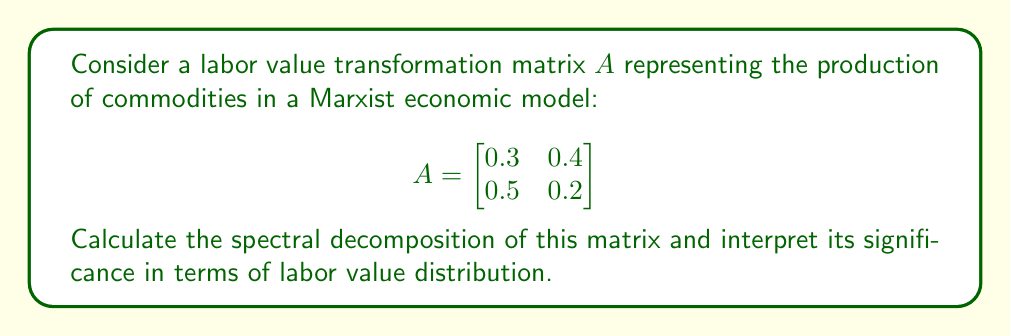Teach me how to tackle this problem. To calculate the spectral decomposition of matrix $A$, we follow these steps:

1) Find the eigenvalues of $A$:
   Characteristic equation: $det(A - \lambda I) = 0$
   $$ \begin{vmatrix}
   0.3 - \lambda & 0.4 \\
   0.5 & 0.2 - \lambda
   \end{vmatrix} = 0 $$
   $(0.3 - \lambda)(0.2 - \lambda) - 0.2 = 0$
   $\lambda^2 - 0.5\lambda - 0.14 = 0$
   Solving this quadratic equation, we get:
   $\lambda_1 \approx 0.7236$ and $\lambda_2 \approx -0.2236$

2) Find the eigenvectors for each eigenvalue:
   For $\lambda_1 \approx 0.7236$:
   $$(A - 0.7236I)v_1 = 0$$
   Solving this, we get $v_1 \approx [0.7071, 0.7071]^T$
   
   For $\lambda_2 \approx -0.2236$:
   $$(A + 0.2236I)v_2 = 0$$
   Solving this, we get $v_2 \approx [-0.7071, 0.7071]^T$

3) Form the matrix $P$ of eigenvectors and diagonal matrix $D$ of eigenvalues:
   $$ P \approx \begin{bmatrix}
   0.7071 & -0.7071 \\
   0.7071 & 0.7071
   \end{bmatrix} $$
   $$ D \approx \begin{bmatrix}
   0.7236 & 0 \\
   0 & -0.2236
   \end{bmatrix} $$

4) The spectral decomposition is given by $A = PDP^{-1}$

Interpretation: The spectral decomposition reveals the fundamental structure of labor value transformation. The dominant eigenvalue (0.7236) represents the long-term growth rate of the system, while its corresponding eigenvector shows the relative proportions of commodities in the economy's stable state. The negative eigenvalue (-0.2236) indicates oscillations in the short-term distribution of labor value between sectors.
Answer: $A = PDP^{-1}$, where $P \approx \begin{bmatrix} 0.7071 & -0.7071 \\ 0.7071 & 0.7071 \end{bmatrix}$ and $D \approx \begin{bmatrix} 0.7236 & 0 \\ 0 & -0.2236 \end{bmatrix}$ 